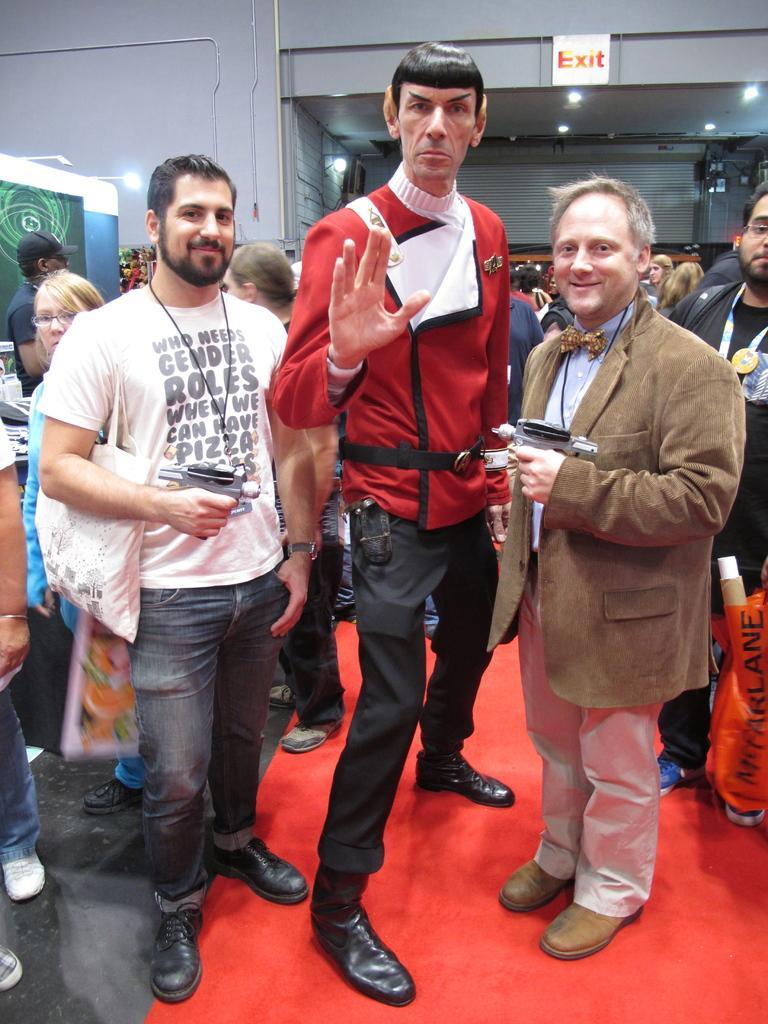In one or two sentences, can you explain what this image depicts? In the center of the image we can see three persons are standing and they are in different costumes. Among them, we can see two persons are holding some objects and they are smiling and the left side person is wearing a bag. In the background there is a wall, sign board, lights, few people are standing, few people are holding some objects and a few other objects. 